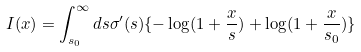<formula> <loc_0><loc_0><loc_500><loc_500>I ( x ) = \int _ { s _ { 0 } } ^ { \infty } d s \sigma ^ { \prime } ( s ) \{ - \log ( 1 + \frac { x } { s } ) + \log ( 1 + \frac { x } { s _ { 0 } } ) \}</formula> 